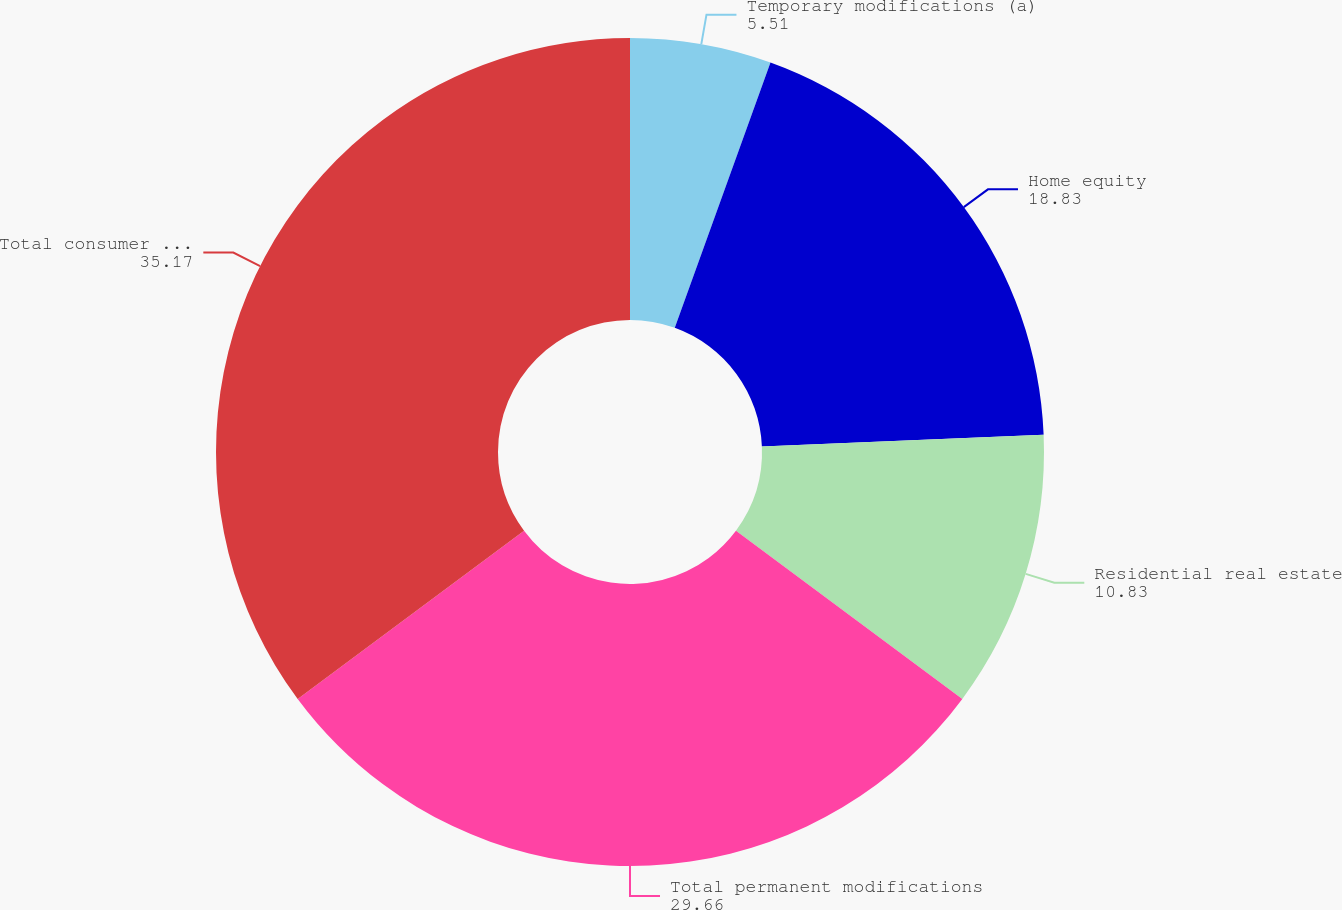<chart> <loc_0><loc_0><loc_500><loc_500><pie_chart><fcel>Temporary modifications (a)<fcel>Home equity<fcel>Residential real estate<fcel>Total permanent modifications<fcel>Total consumer real estate<nl><fcel>5.51%<fcel>18.83%<fcel>10.83%<fcel>29.66%<fcel>35.17%<nl></chart> 